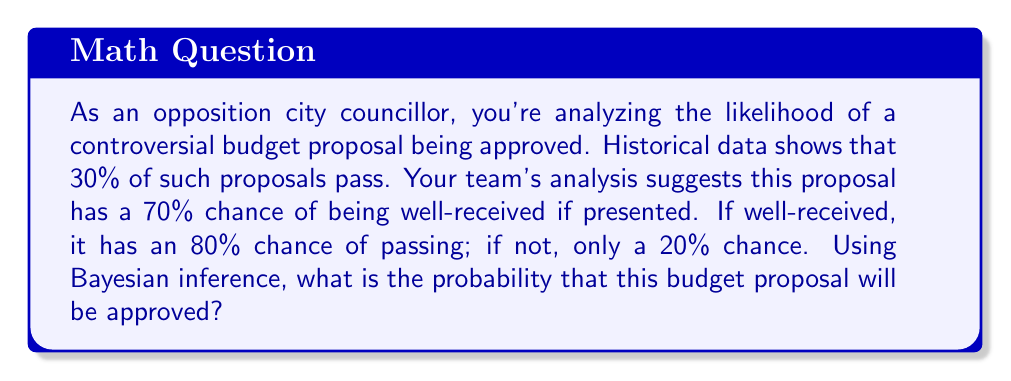Can you answer this question? Let's approach this step-by-step using Bayesian inference:

1) Define our events:
   A: The proposal is approved
   B: The proposal is well-received

2) Given probabilities:
   P(A) = 0.30 (prior probability of approval)
   P(B) = 0.70 (probability of being well-received)
   P(A|B) = 0.80 (probability of approval if well-received)
   P(A|not B) = 0.20 (probability of approval if not well-received)

3) We want to find P(A|B) using Bayes' theorem:

   $$P(A|B) = \frac{P(B|A) \cdot P(A)}{P(B)}$$

4) We need to find P(B|A):

   $$P(B|A) = \frac{P(A|B) \cdot P(B)}{P(A)} = \frac{0.80 \cdot 0.70}{0.30} = 1.87$$

5) Now we can apply Bayes' theorem:

   $$P(A|B) = \frac{1.87 \cdot 0.30}{0.70} = 0.80$$

6) This gives us P(A|B), but we want the overall probability of approval. We can use the law of total probability:

   $$P(A) = P(A|B) \cdot P(B) + P(A|not B) \cdot P(not B)$$

7) Plugging in our values:

   $$P(A) = 0.80 \cdot 0.70 + 0.20 \cdot (1 - 0.70) = 0.56 + 0.06 = 0.62$$

Therefore, the probability of the budget proposal being approved is 0.62 or 62%.
Answer: 0.62 